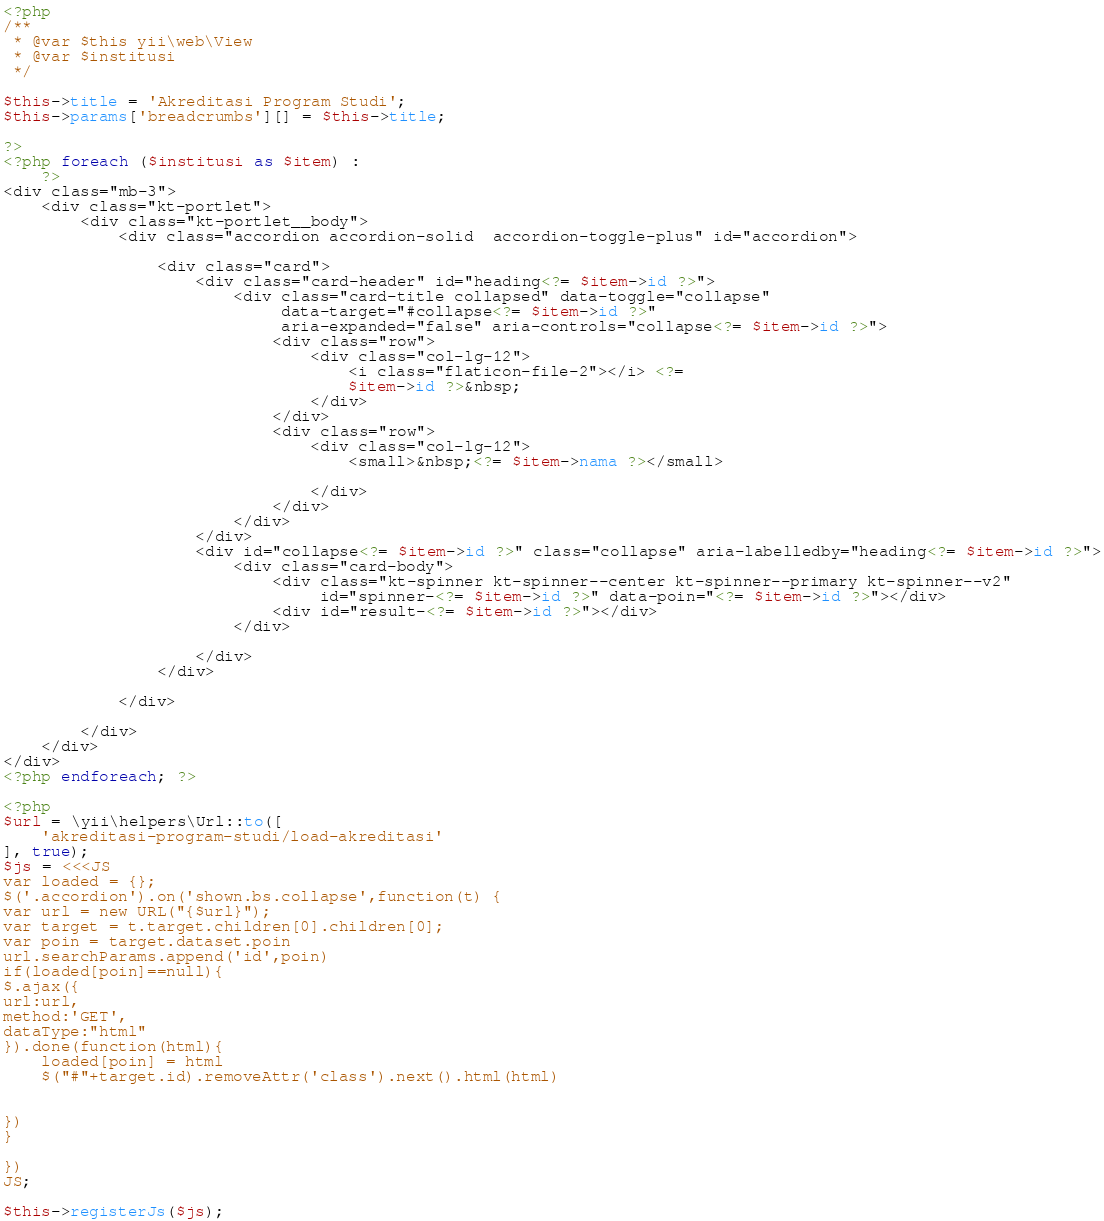<code> <loc_0><loc_0><loc_500><loc_500><_PHP_><?php
/**
 * @var $this yii\web\View
 * @var $institusi
 */

$this->title = 'Akreditasi Program Studi';
$this->params['breadcrumbs'][] = $this->title;

?>
<?php foreach ($institusi as $item) :
    ?>
<div class="mb-3">
    <div class="kt-portlet">
        <div class="kt-portlet__body">
            <div class="accordion accordion-solid  accordion-toggle-plus" id="accordion">

                <div class="card">
                    <div class="card-header" id="heading<?= $item->id ?>">
                        <div class="card-title collapsed" data-toggle="collapse"
                             data-target="#collapse<?= $item->id ?>"
                             aria-expanded="false" aria-controls="collapse<?= $item->id ?>">
                            <div class="row">
                                <div class="col-lg-12">
                                    <i class="flaticon-file-2"></i> <?=
                                    $item->id ?>&nbsp;
                                </div>
                            </div>
                            <div class="row">
                                <div class="col-lg-12">
                                    <small>&nbsp;<?= $item->nama ?></small>

                                </div>
                            </div>
                        </div>
                    </div>
                    <div id="collapse<?= $item->id ?>" class="collapse" aria-labelledby="heading<?= $item->id ?>">
                        <div class="card-body">
                            <div class="kt-spinner kt-spinner--center kt-spinner--primary kt-spinner--v2"
                                 id="spinner-<?= $item->id ?>" data-poin="<?= $item->id ?>"></div>
                            <div id="result-<?= $item->id ?>"></div>
                        </div>

                    </div>
                </div>

            </div>

        </div>
    </div>
</div>
<?php endforeach; ?>

<?php
$url = \yii\helpers\Url::to([
    'akreditasi-program-studi/load-akreditasi'
], true);
$js = <<<JS
var loaded = {};
$('.accordion').on('shown.bs.collapse',function(t) {
var url = new URL("{$url}");
var target = t.target.children[0].children[0];
var poin = target.dataset.poin
url.searchParams.append('id',poin)
if(loaded[poin]==null){
$.ajax({
url:url,
method:'GET',
dataType:"html"
}).done(function(html){
    loaded[poin] = html
    $("#"+target.id).removeAttr('class').next().html(html)


})
}

})
JS;

$this->registerJs($js);

</code> 